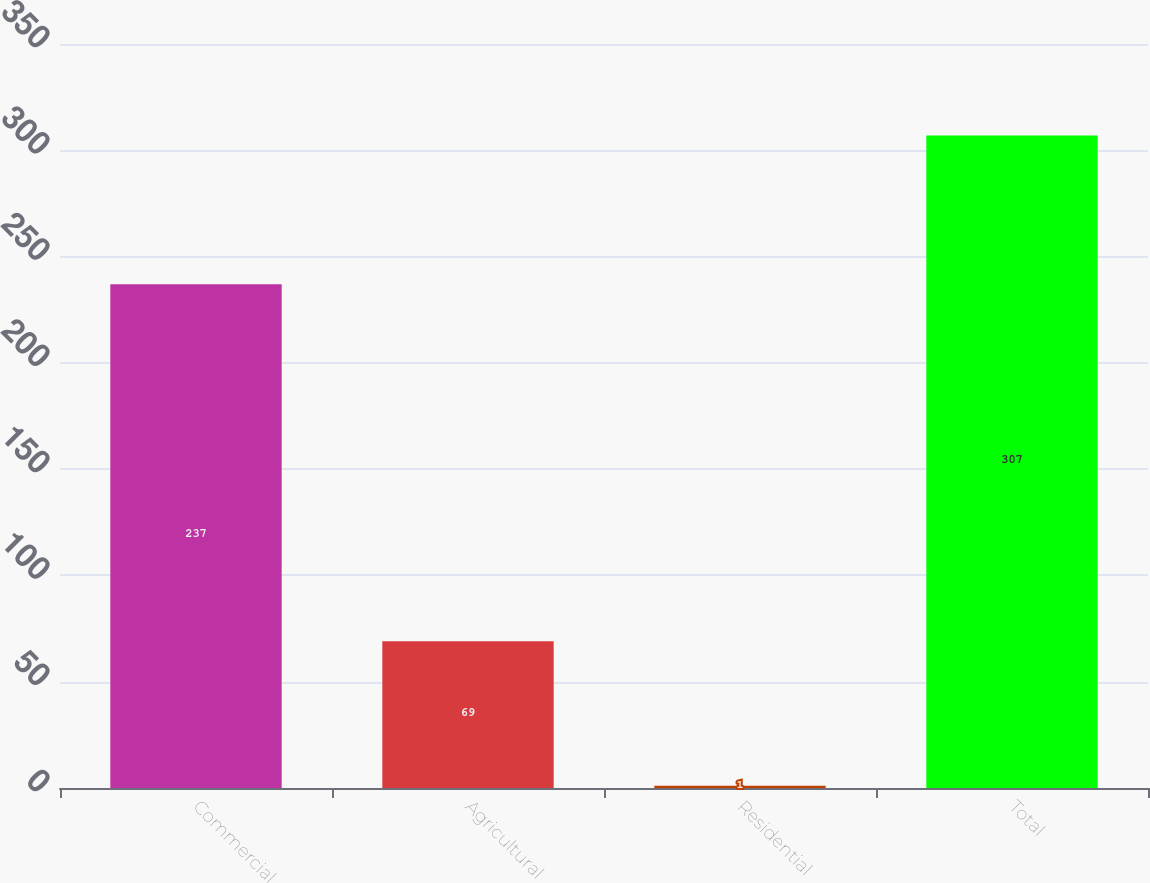Convert chart to OTSL. <chart><loc_0><loc_0><loc_500><loc_500><bar_chart><fcel>Commercial<fcel>Agricultural<fcel>Residential<fcel>Total<nl><fcel>237<fcel>69<fcel>1<fcel>307<nl></chart> 